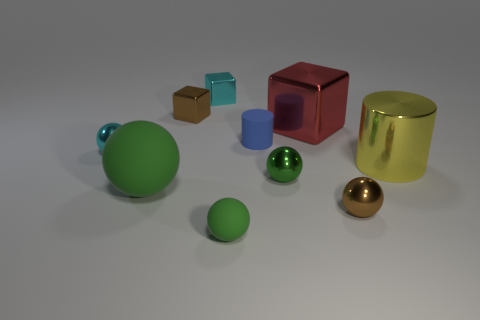How many other objects are the same size as the blue rubber thing?
Give a very brief answer. 6. How many large things are there?
Provide a succinct answer. 3. Is the number of yellow things that are to the left of the tiny cyan sphere less than the number of small cubes on the right side of the large red metallic object?
Offer a terse response. No. Is the number of metallic cubes that are to the left of the large matte thing less than the number of red metal things?
Offer a very short reply. Yes. What is the material of the big thing behind the yellow metallic thing that is right of the small brown thing that is on the right side of the small green metal thing?
Your answer should be compact. Metal. What number of things are either small metal spheres that are right of the blue matte cylinder or green spheres that are in front of the tiny cylinder?
Your answer should be very brief. 4. There is a cyan object that is the same shape as the tiny green rubber thing; what is it made of?
Provide a short and direct response. Metal. How many matte things are large red cylinders or small brown objects?
Your answer should be very brief. 0. What shape is the tiny brown thing that is made of the same material as the small brown cube?
Offer a very short reply. Sphere. How many green metal objects have the same shape as the big rubber thing?
Your answer should be very brief. 1. 